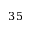Convert formula to latex. <formula><loc_0><loc_0><loc_500><loc_500>3 5</formula> 